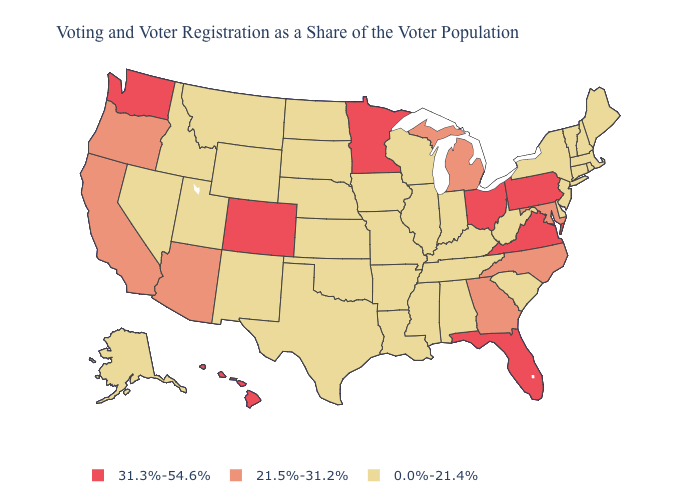Does Iowa have the same value as California?
Concise answer only. No. Which states have the lowest value in the Northeast?
Quick response, please. Connecticut, Maine, Massachusetts, New Hampshire, New Jersey, New York, Rhode Island, Vermont. Name the states that have a value in the range 0.0%-21.4%?
Short answer required. Alabama, Alaska, Arkansas, Connecticut, Delaware, Idaho, Illinois, Indiana, Iowa, Kansas, Kentucky, Louisiana, Maine, Massachusetts, Mississippi, Missouri, Montana, Nebraska, Nevada, New Hampshire, New Jersey, New Mexico, New York, North Dakota, Oklahoma, Rhode Island, South Carolina, South Dakota, Tennessee, Texas, Utah, Vermont, West Virginia, Wisconsin, Wyoming. Name the states that have a value in the range 0.0%-21.4%?
Be succinct. Alabama, Alaska, Arkansas, Connecticut, Delaware, Idaho, Illinois, Indiana, Iowa, Kansas, Kentucky, Louisiana, Maine, Massachusetts, Mississippi, Missouri, Montana, Nebraska, Nevada, New Hampshire, New Jersey, New Mexico, New York, North Dakota, Oklahoma, Rhode Island, South Carolina, South Dakota, Tennessee, Texas, Utah, Vermont, West Virginia, Wisconsin, Wyoming. Name the states that have a value in the range 0.0%-21.4%?
Quick response, please. Alabama, Alaska, Arkansas, Connecticut, Delaware, Idaho, Illinois, Indiana, Iowa, Kansas, Kentucky, Louisiana, Maine, Massachusetts, Mississippi, Missouri, Montana, Nebraska, Nevada, New Hampshire, New Jersey, New Mexico, New York, North Dakota, Oklahoma, Rhode Island, South Carolina, South Dakota, Tennessee, Texas, Utah, Vermont, West Virginia, Wisconsin, Wyoming. Does the map have missing data?
Be succinct. No. What is the highest value in the USA?
Concise answer only. 31.3%-54.6%. What is the value of Alabama?
Give a very brief answer. 0.0%-21.4%. Name the states that have a value in the range 31.3%-54.6%?
Write a very short answer. Colorado, Florida, Hawaii, Minnesota, Ohio, Pennsylvania, Virginia, Washington. What is the lowest value in states that border Rhode Island?
Quick response, please. 0.0%-21.4%. Does Vermont have a lower value than New Mexico?
Give a very brief answer. No. What is the value of New Hampshire?
Short answer required. 0.0%-21.4%. What is the value of North Dakota?
Answer briefly. 0.0%-21.4%. Which states have the lowest value in the South?
Give a very brief answer. Alabama, Arkansas, Delaware, Kentucky, Louisiana, Mississippi, Oklahoma, South Carolina, Tennessee, Texas, West Virginia. Name the states that have a value in the range 31.3%-54.6%?
Keep it brief. Colorado, Florida, Hawaii, Minnesota, Ohio, Pennsylvania, Virginia, Washington. 